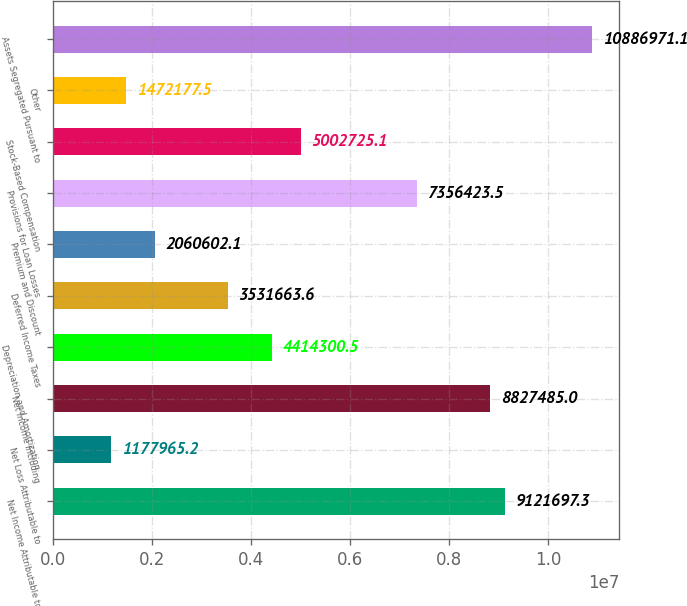Convert chart. <chart><loc_0><loc_0><loc_500><loc_500><bar_chart><fcel>Net Income Attributable to<fcel>Net Loss Attributable to<fcel>Net Income Including<fcel>Depreciation and Amortization<fcel>Deferred Income Taxes<fcel>Premium and Discount<fcel>Provisions for Loan Losses<fcel>Stock-Based Compensation<fcel>Other<fcel>Assets Segregated Pursuant to<nl><fcel>9.1217e+06<fcel>1.17797e+06<fcel>8.82748e+06<fcel>4.4143e+06<fcel>3.53166e+06<fcel>2.0606e+06<fcel>7.35642e+06<fcel>5.00273e+06<fcel>1.47218e+06<fcel>1.0887e+07<nl></chart> 